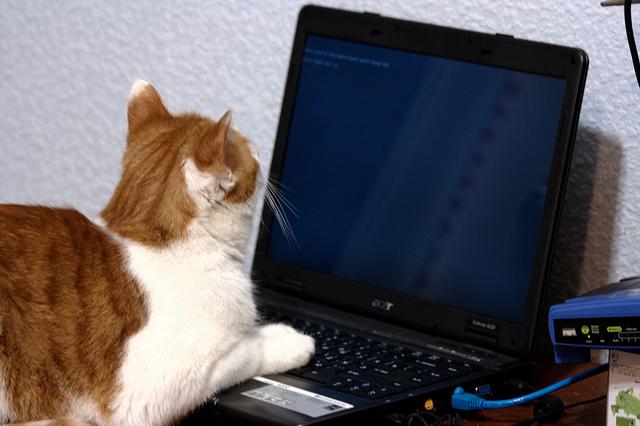Is the cat wearing something?
Quick response, please. No. Is the cat warming its paws?
Short answer required. No. Is the cat using the computer?
Answer briefly. Yes. Is this cat trying to learn how to type on a computer keyboard?
Short answer required. No. Is the cat talking on the phone?
Keep it brief. No. 